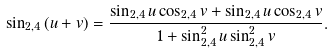Convert formula to latex. <formula><loc_0><loc_0><loc_500><loc_500>\sin _ { 2 , 4 } { ( u + v ) } = \frac { \sin _ { 2 , 4 } { u } \cos _ { 2 , 4 } { v } + \sin _ { 2 , 4 } { u } \cos _ { 2 , 4 } { v } } { 1 + \sin _ { 2 , 4 } ^ { 2 } { u } \sin _ { 2 , 4 } ^ { 2 } { v } } .</formula> 